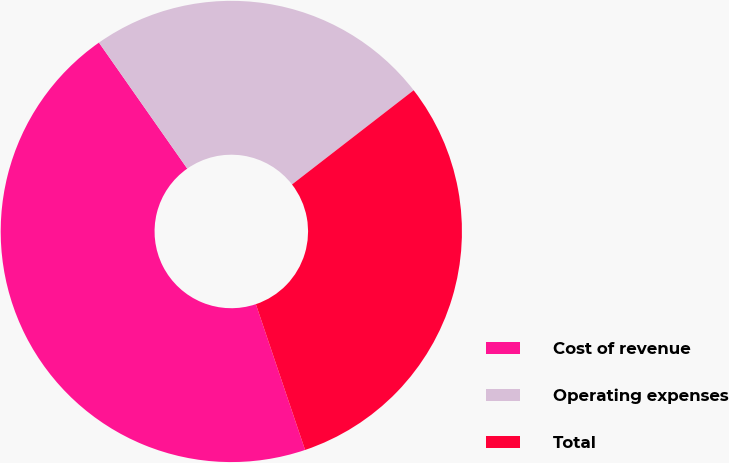Convert chart to OTSL. <chart><loc_0><loc_0><loc_500><loc_500><pie_chart><fcel>Cost of revenue<fcel>Operating expenses<fcel>Total<nl><fcel>45.45%<fcel>24.24%<fcel>30.3%<nl></chart> 